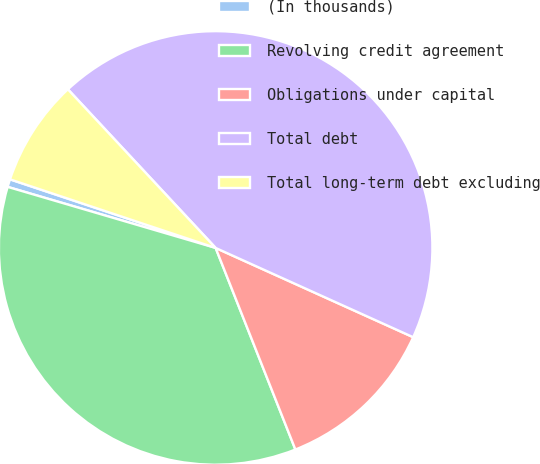Convert chart. <chart><loc_0><loc_0><loc_500><loc_500><pie_chart><fcel>(In thousands)<fcel>Revolving credit agreement<fcel>Obligations under capital<fcel>Total debt<fcel>Total long-term debt excluding<nl><fcel>0.58%<fcel>35.54%<fcel>12.25%<fcel>43.69%<fcel>7.94%<nl></chart> 